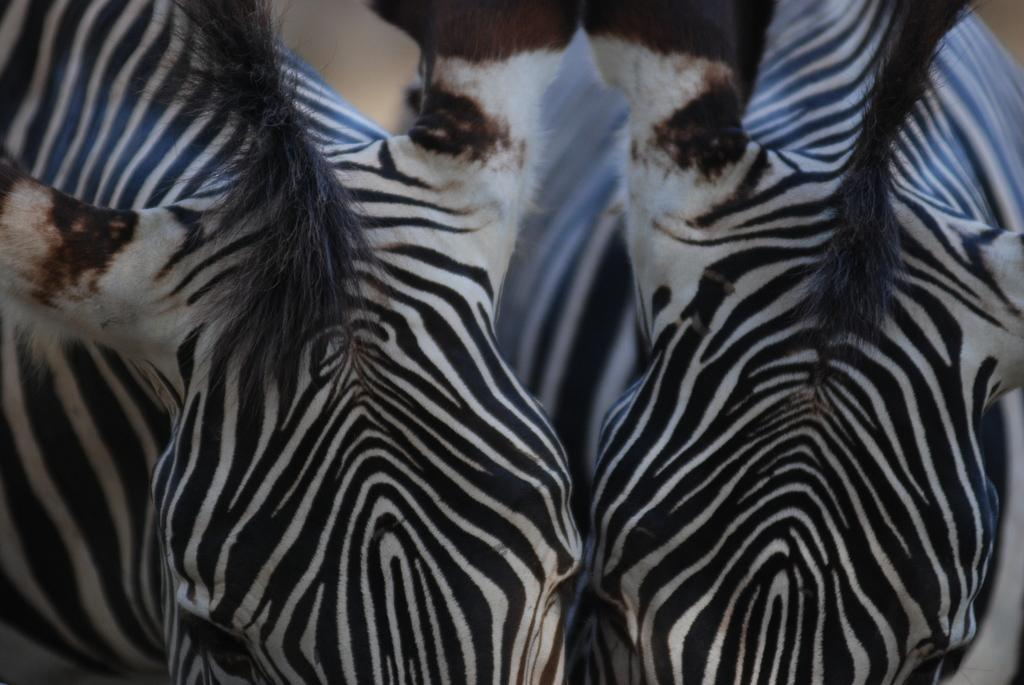What animals are present in the image? There are two zebras in the image. What type of jewel is the zebra wearing around its neck in the image? There is no jewel visible around the zebras' necks in the image. What rule is the zebra following in the image? There is no rule or behavior being depicted in the image; it simply shows two zebras. 